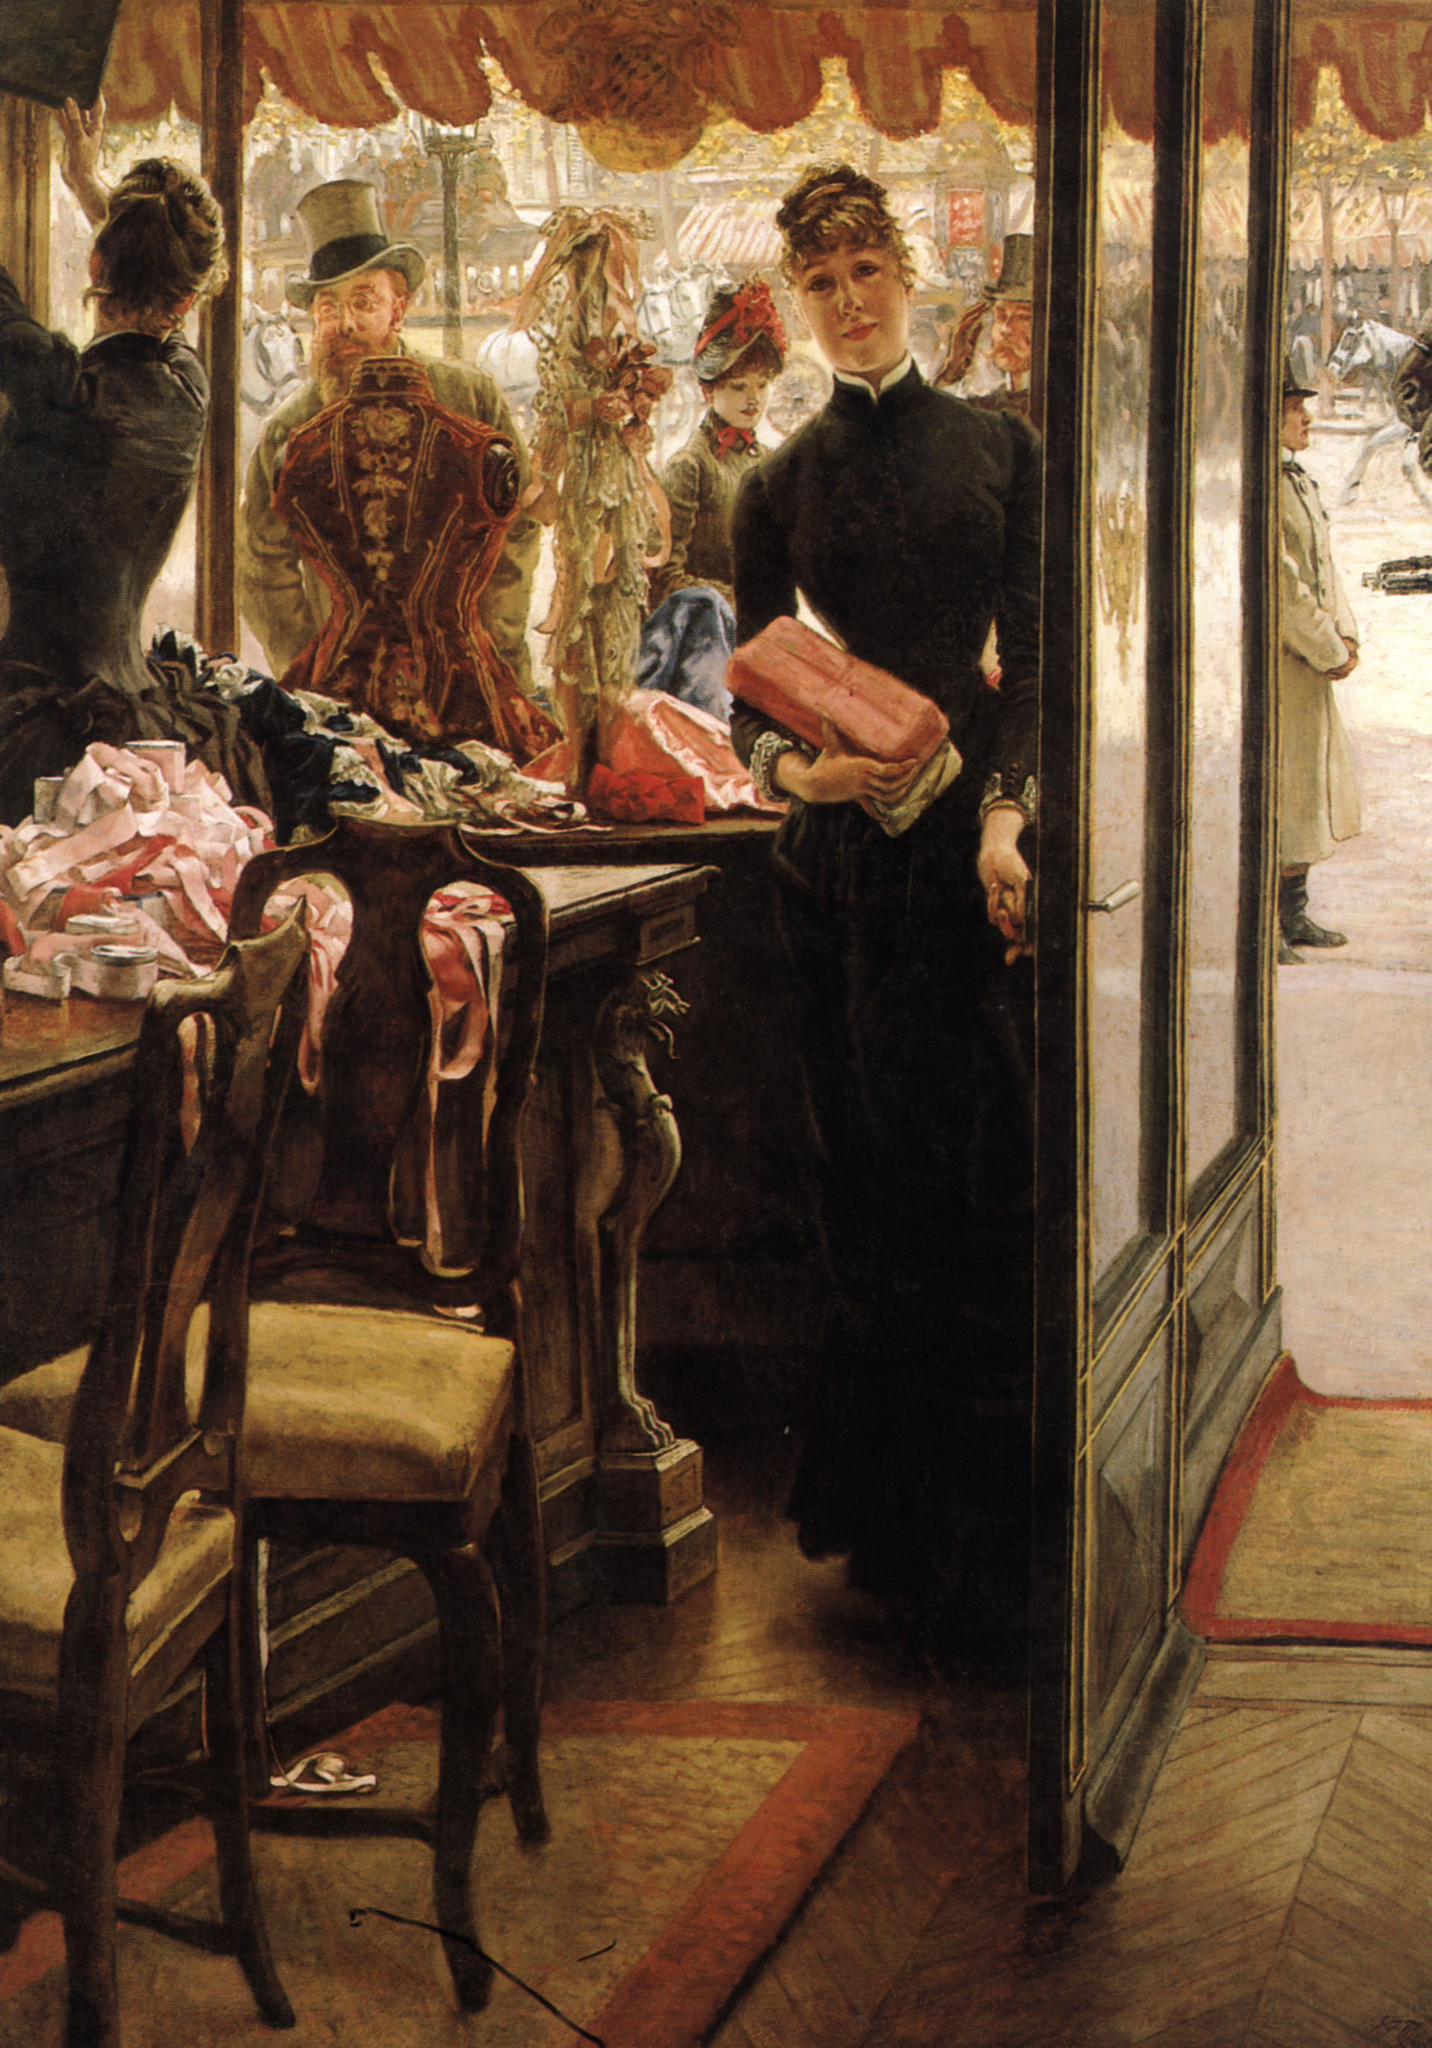Can you describe the smallest details of this painting and their possible significance? The painting is replete with minute but significant details. The shop girl’s black dress is adorned with delicate lace cuffs, emphasizing her modest yet refined appearance. On the counter, a scattering of ribbons and bonnets symbolize the intricacy and care involved in the daily workings of the shop. The reflection in the window subtly mirrors the internal and external worlds colliding; the detailed texture of the wooden floor and the elegant furnishings highlight the boutique's luxury. Outside, the cobblestone street and the varied expressions of the passersby suggest a vibrant yet contrasting world compared to the calm inside. Each detail adds layers of realism and narrative depth, making viewers ponder the personal stories behind every element. If this painting could come to life, what do you think would happen next? If this painting could come to life, the scene would unfold with a sudden buzz as more customers entered the shop. Eliza would graciously attend to them, her gentle demeanor winning the trust and affection of the ladies selecting fine ribbons and bonnets. Outside, a cacophony of horses and street vendors would fill the air, as a gentleman slowed his pace, catching a glimpse of the delicate scene within. He might enter, intrigued not just by the beautiful items but by the composed, graceful shop girl, setting the stage for an unexpected encounter that could change both their futures. The shop would be a hum of laughter and conversation, with the day's routine blending seamlessly into the early evening, where the twilight would cast long shadows, painting the shop’s interior with a golden hue. 